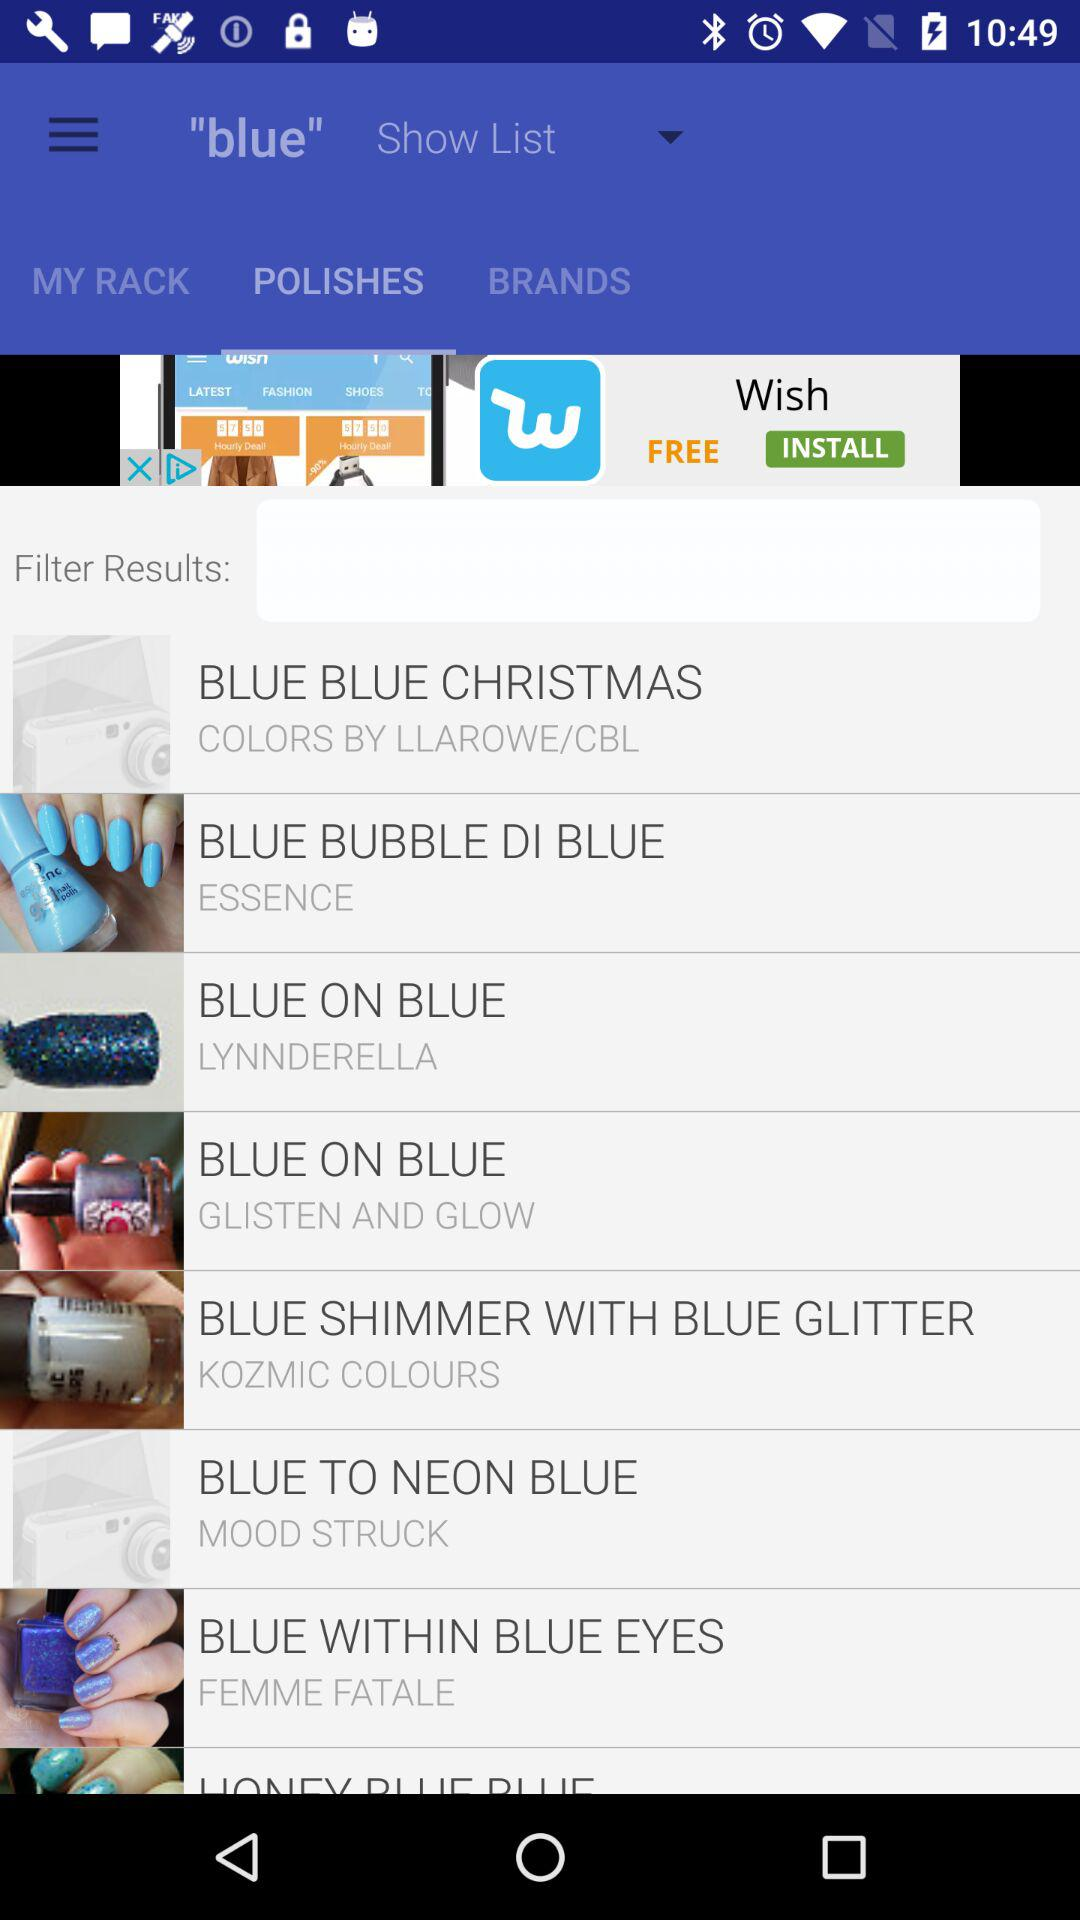Which tab is selected? The selected tab is "POLISHES". 